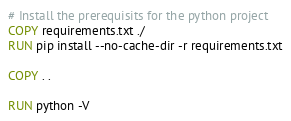Convert code to text. <code><loc_0><loc_0><loc_500><loc_500><_Dockerfile_># Install the prerequisits for the python project
COPY requirements.txt ./
RUN pip install --no-cache-dir -r requirements.txt

COPY . .

RUN python -V</code> 